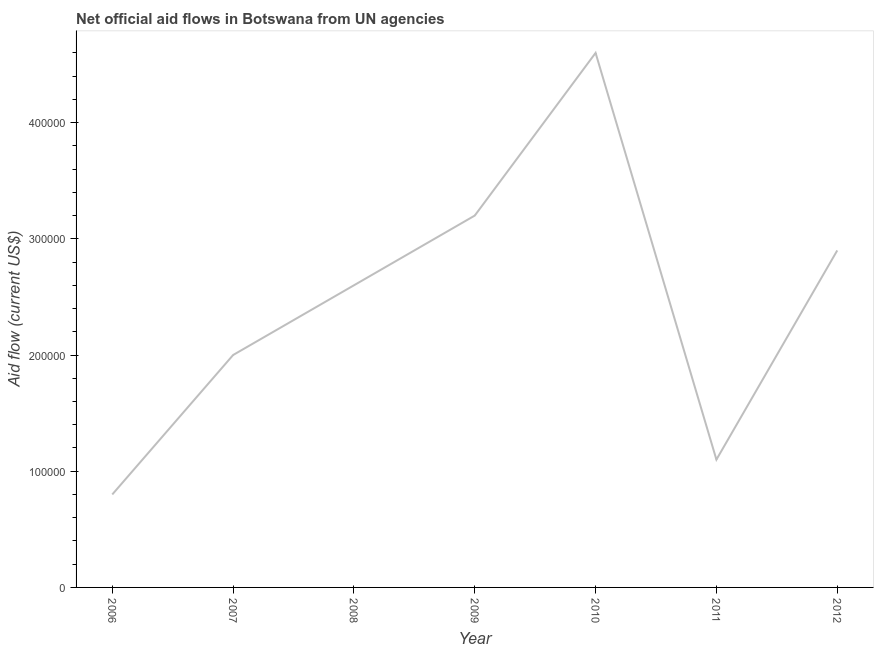What is the net official flows from un agencies in 2007?
Your answer should be compact. 2.00e+05. Across all years, what is the maximum net official flows from un agencies?
Provide a succinct answer. 4.60e+05. Across all years, what is the minimum net official flows from un agencies?
Your answer should be compact. 8.00e+04. In which year was the net official flows from un agencies maximum?
Your response must be concise. 2010. What is the sum of the net official flows from un agencies?
Provide a short and direct response. 1.72e+06. What is the difference between the net official flows from un agencies in 2007 and 2008?
Your answer should be very brief. -6.00e+04. What is the average net official flows from un agencies per year?
Offer a terse response. 2.46e+05. What is the median net official flows from un agencies?
Offer a very short reply. 2.60e+05. In how many years, is the net official flows from un agencies greater than 420000 US$?
Your response must be concise. 1. Do a majority of the years between 2011 and 2007 (inclusive) have net official flows from un agencies greater than 20000 US$?
Ensure brevity in your answer.  Yes. What is the ratio of the net official flows from un agencies in 2006 to that in 2009?
Offer a very short reply. 0.25. Is the net official flows from un agencies in 2008 less than that in 2011?
Keep it short and to the point. No. Is the difference between the net official flows from un agencies in 2006 and 2012 greater than the difference between any two years?
Ensure brevity in your answer.  No. What is the difference between the highest and the second highest net official flows from un agencies?
Offer a terse response. 1.40e+05. Is the sum of the net official flows from un agencies in 2006 and 2012 greater than the maximum net official flows from un agencies across all years?
Provide a short and direct response. No. What is the difference between the highest and the lowest net official flows from un agencies?
Offer a terse response. 3.80e+05. In how many years, is the net official flows from un agencies greater than the average net official flows from un agencies taken over all years?
Ensure brevity in your answer.  4. Does the graph contain grids?
Provide a short and direct response. No. What is the title of the graph?
Your response must be concise. Net official aid flows in Botswana from UN agencies. What is the label or title of the Y-axis?
Your answer should be compact. Aid flow (current US$). What is the Aid flow (current US$) in 2007?
Provide a short and direct response. 2.00e+05. What is the Aid flow (current US$) in 2009?
Give a very brief answer. 3.20e+05. What is the Aid flow (current US$) of 2010?
Your response must be concise. 4.60e+05. What is the difference between the Aid flow (current US$) in 2006 and 2007?
Your answer should be very brief. -1.20e+05. What is the difference between the Aid flow (current US$) in 2006 and 2009?
Provide a succinct answer. -2.40e+05. What is the difference between the Aid flow (current US$) in 2006 and 2010?
Your answer should be compact. -3.80e+05. What is the difference between the Aid flow (current US$) in 2007 and 2008?
Keep it short and to the point. -6.00e+04. What is the difference between the Aid flow (current US$) in 2007 and 2009?
Your answer should be very brief. -1.20e+05. What is the difference between the Aid flow (current US$) in 2008 and 2009?
Give a very brief answer. -6.00e+04. What is the difference between the Aid flow (current US$) in 2008 and 2011?
Your answer should be very brief. 1.50e+05. What is the difference between the Aid flow (current US$) in 2009 and 2010?
Your answer should be compact. -1.40e+05. What is the difference between the Aid flow (current US$) in 2010 and 2011?
Offer a terse response. 3.50e+05. What is the difference between the Aid flow (current US$) in 2011 and 2012?
Give a very brief answer. -1.80e+05. What is the ratio of the Aid flow (current US$) in 2006 to that in 2007?
Ensure brevity in your answer.  0.4. What is the ratio of the Aid flow (current US$) in 2006 to that in 2008?
Your answer should be compact. 0.31. What is the ratio of the Aid flow (current US$) in 2006 to that in 2010?
Give a very brief answer. 0.17. What is the ratio of the Aid flow (current US$) in 2006 to that in 2011?
Offer a very short reply. 0.73. What is the ratio of the Aid flow (current US$) in 2006 to that in 2012?
Your answer should be compact. 0.28. What is the ratio of the Aid flow (current US$) in 2007 to that in 2008?
Give a very brief answer. 0.77. What is the ratio of the Aid flow (current US$) in 2007 to that in 2009?
Keep it short and to the point. 0.62. What is the ratio of the Aid flow (current US$) in 2007 to that in 2010?
Your answer should be compact. 0.43. What is the ratio of the Aid flow (current US$) in 2007 to that in 2011?
Your answer should be very brief. 1.82. What is the ratio of the Aid flow (current US$) in 2007 to that in 2012?
Provide a short and direct response. 0.69. What is the ratio of the Aid flow (current US$) in 2008 to that in 2009?
Offer a terse response. 0.81. What is the ratio of the Aid flow (current US$) in 2008 to that in 2010?
Keep it short and to the point. 0.56. What is the ratio of the Aid flow (current US$) in 2008 to that in 2011?
Make the answer very short. 2.36. What is the ratio of the Aid flow (current US$) in 2008 to that in 2012?
Provide a short and direct response. 0.9. What is the ratio of the Aid flow (current US$) in 2009 to that in 2010?
Give a very brief answer. 0.7. What is the ratio of the Aid flow (current US$) in 2009 to that in 2011?
Your answer should be compact. 2.91. What is the ratio of the Aid flow (current US$) in 2009 to that in 2012?
Your answer should be compact. 1.1. What is the ratio of the Aid flow (current US$) in 2010 to that in 2011?
Make the answer very short. 4.18. What is the ratio of the Aid flow (current US$) in 2010 to that in 2012?
Your response must be concise. 1.59. What is the ratio of the Aid flow (current US$) in 2011 to that in 2012?
Provide a succinct answer. 0.38. 